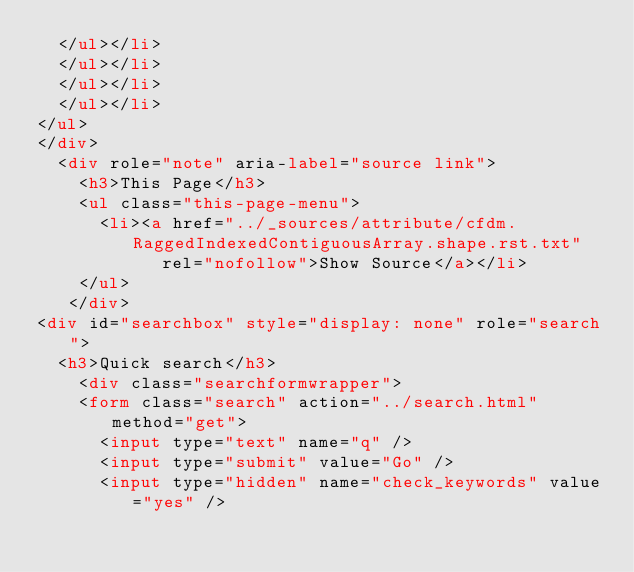Convert code to text. <code><loc_0><loc_0><loc_500><loc_500><_HTML_>  </ul></li>
  </ul></li>
  </ul></li>
  </ul></li>
</ul>
</div>
  <div role="note" aria-label="source link">
    <h3>This Page</h3>
    <ul class="this-page-menu">
      <li><a href="../_sources/attribute/cfdm.RaggedIndexedContiguousArray.shape.rst.txt"
            rel="nofollow">Show Source</a></li>
    </ul>
   </div>
<div id="searchbox" style="display: none" role="search">
  <h3>Quick search</h3>
    <div class="searchformwrapper">
    <form class="search" action="../search.html" method="get">
      <input type="text" name="q" />
      <input type="submit" value="Go" />
      <input type="hidden" name="check_keywords" value="yes" /></code> 